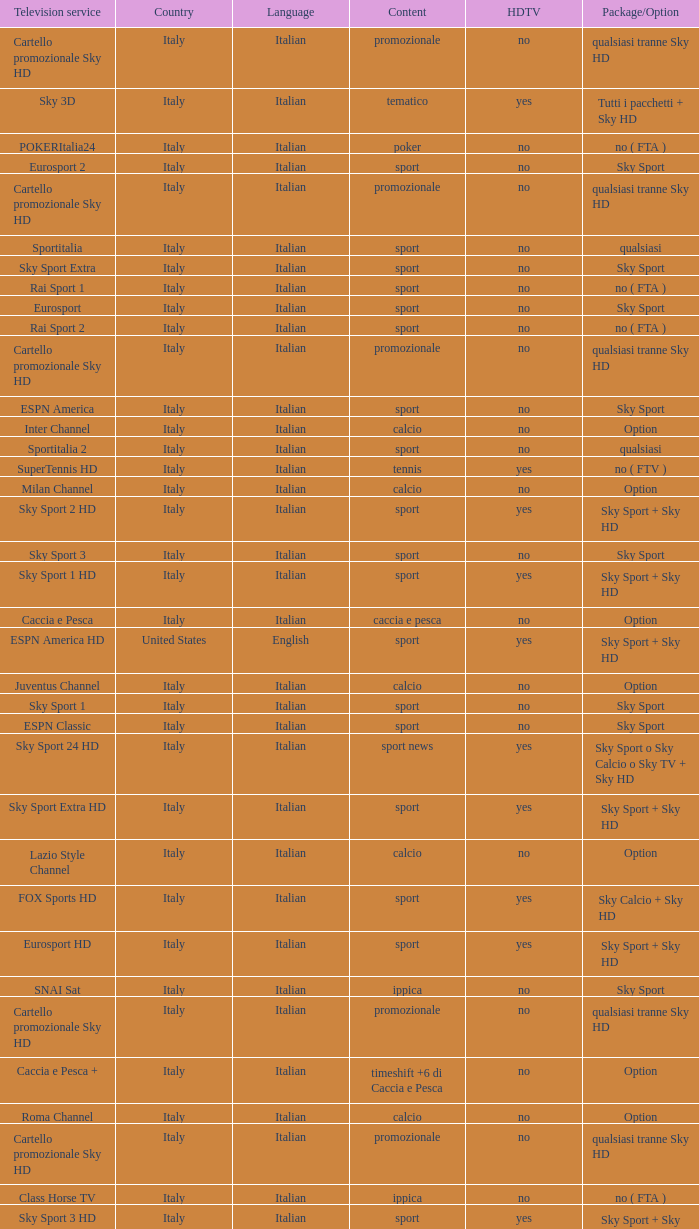What is Package/Option, when Content is Tennis? No ( ftv ). 